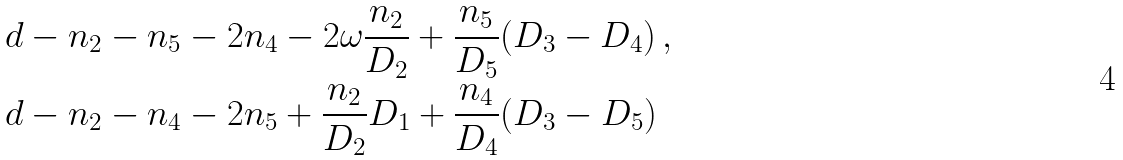<formula> <loc_0><loc_0><loc_500><loc_500>& d - n _ { 2 } - n _ { 5 } - 2 n _ { 4 } - 2 \omega \frac { n _ { 2 } } { D _ { 2 } } + \frac { n _ { 5 } } { D _ { 5 } } ( D _ { 3 } - D _ { 4 } ) \, , \\ & d - n _ { 2 } - n _ { 4 } - 2 n _ { 5 } + \frac { n _ { 2 } } { D _ { 2 } } D _ { 1 } + \frac { n _ { 4 } } { D _ { 4 } } ( D _ { 3 } - D _ { 5 } )</formula> 